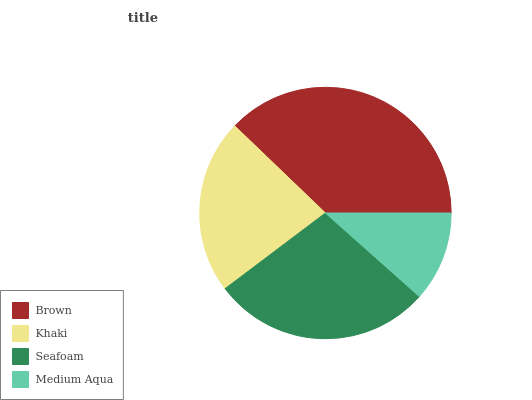Is Medium Aqua the minimum?
Answer yes or no. Yes. Is Brown the maximum?
Answer yes or no. Yes. Is Khaki the minimum?
Answer yes or no. No. Is Khaki the maximum?
Answer yes or no. No. Is Brown greater than Khaki?
Answer yes or no. Yes. Is Khaki less than Brown?
Answer yes or no. Yes. Is Khaki greater than Brown?
Answer yes or no. No. Is Brown less than Khaki?
Answer yes or no. No. Is Seafoam the high median?
Answer yes or no. Yes. Is Khaki the low median?
Answer yes or no. Yes. Is Brown the high median?
Answer yes or no. No. Is Brown the low median?
Answer yes or no. No. 